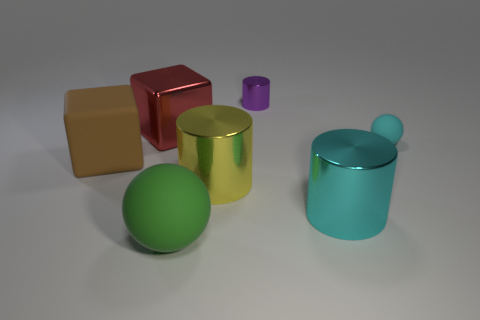Add 2 big things. How many objects exist? 9 Subtract all blocks. How many objects are left? 5 Add 6 tiny cylinders. How many tiny cylinders are left? 7 Add 2 big cyan cylinders. How many big cyan cylinders exist? 3 Subtract 0 cyan blocks. How many objects are left? 7 Subtract all small shiny cylinders. Subtract all blue matte things. How many objects are left? 6 